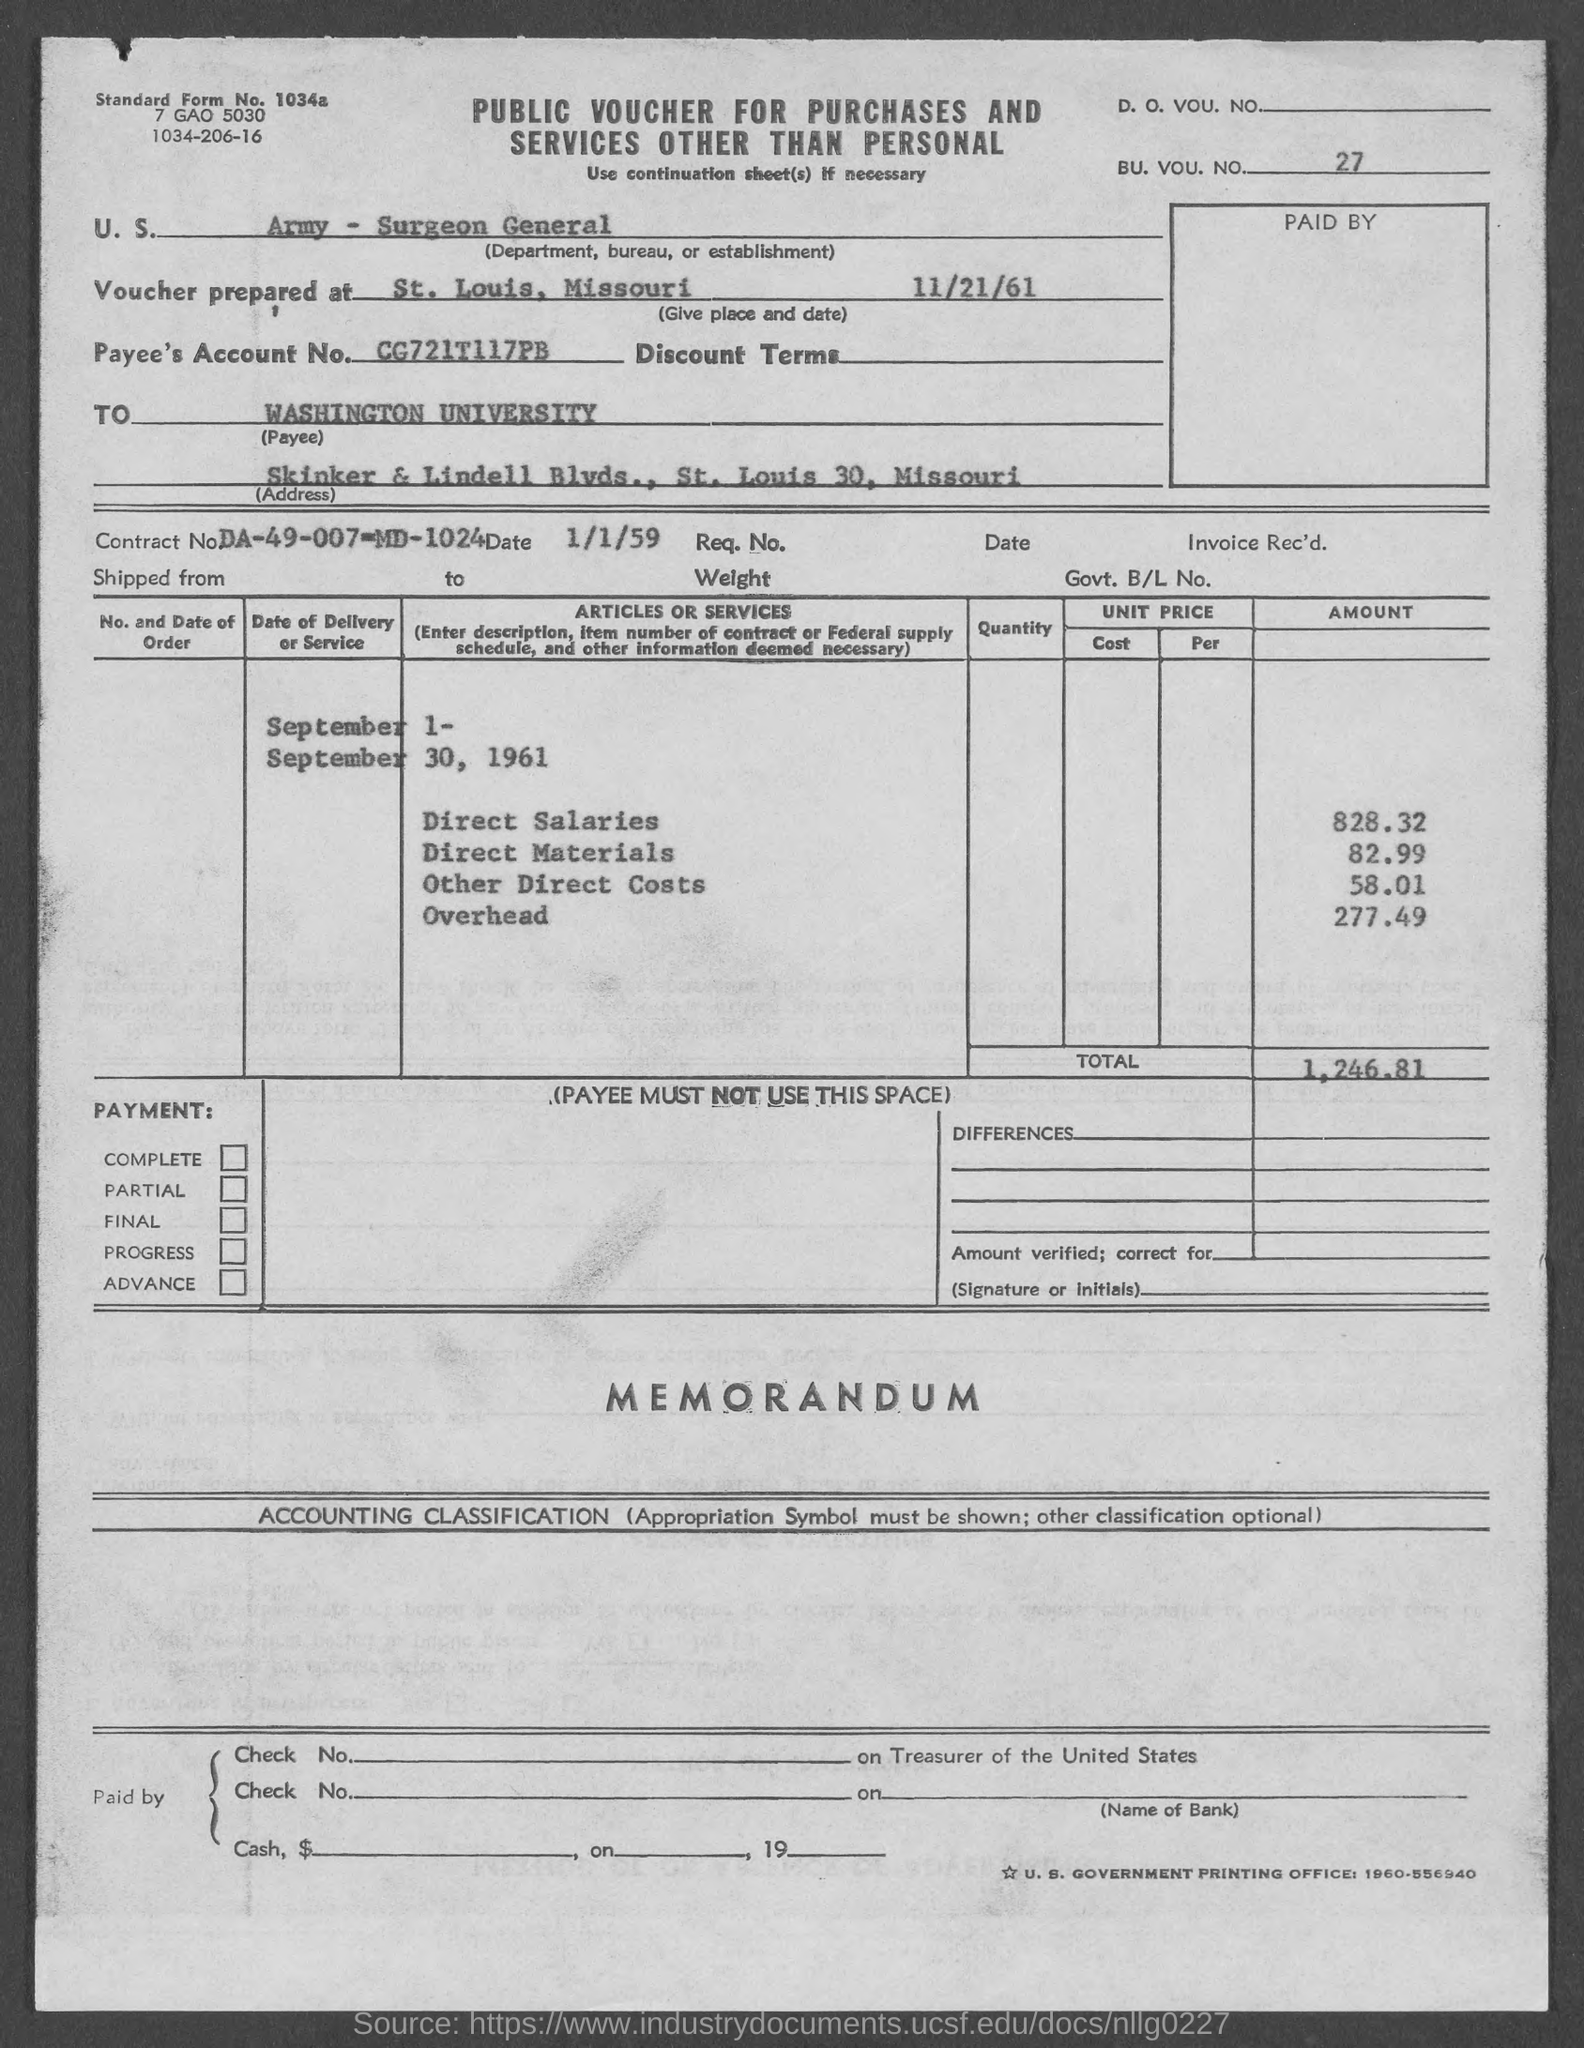what is the amount of Direct Salaries ? The total amount allocated to Direct Salaries as listed on the voucher is $828.32. 